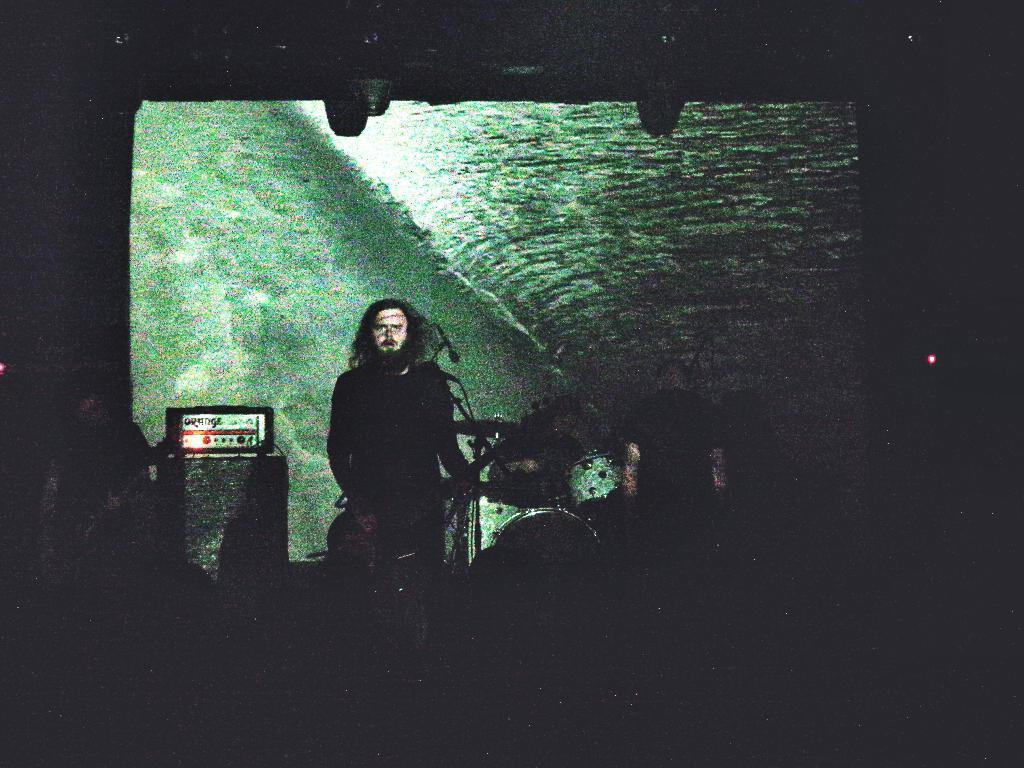What is the main subject of the image? There is a person in the image. What is the person doing in the image? The person is standing and playing a guitar. Can you describe the objects behind the person? Unfortunately, the provided facts do not give any information about the objects behind the person. Is the crook trying to steal the guitar from the person in the image? There is no crook present in the image, so it is not possible to answer that question. 